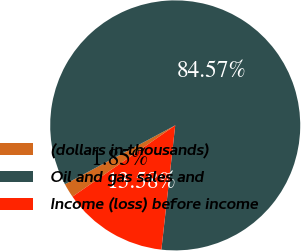<chart> <loc_0><loc_0><loc_500><loc_500><pie_chart><fcel>(dollars in thousands)<fcel>Oil and gas sales and<fcel>Income (loss) before income<nl><fcel>1.85%<fcel>84.57%<fcel>13.58%<nl></chart> 